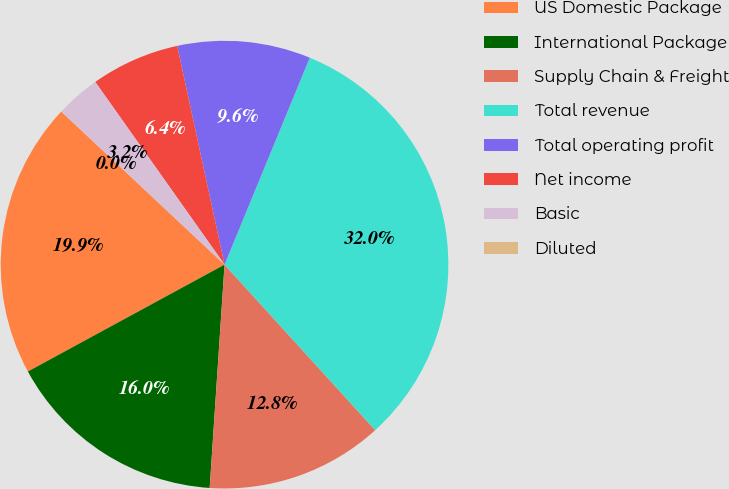<chart> <loc_0><loc_0><loc_500><loc_500><pie_chart><fcel>US Domestic Package<fcel>International Package<fcel>Supply Chain & Freight<fcel>Total revenue<fcel>Total operating profit<fcel>Net income<fcel>Basic<fcel>Diluted<nl><fcel>19.91%<fcel>16.02%<fcel>12.81%<fcel>32.03%<fcel>9.61%<fcel>6.41%<fcel>3.21%<fcel>0.0%<nl></chart> 